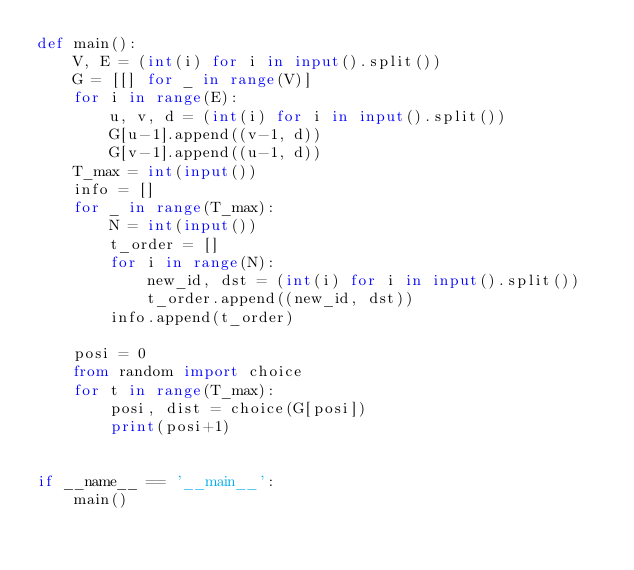Convert code to text. <code><loc_0><loc_0><loc_500><loc_500><_Python_>def main():
    V, E = (int(i) for i in input().split())
    G = [[] for _ in range(V)]
    for i in range(E):
        u, v, d = (int(i) for i in input().split())
        G[u-1].append((v-1, d))
        G[v-1].append((u-1, d))
    T_max = int(input())
    info = []
    for _ in range(T_max):
        N = int(input())
        t_order = []
        for i in range(N):
            new_id, dst = (int(i) for i in input().split())
            t_order.append((new_id, dst))
        info.append(t_order)

    posi = 0
    from random import choice
    for t in range(T_max):
        posi, dist = choice(G[posi])
        print(posi+1)


if __name__ == '__main__':
    main()
</code> 